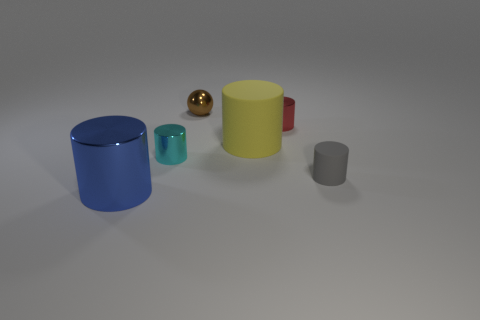There is a big yellow thing that is the same shape as the gray thing; what is it made of? The big yellow object, which has the same cylindrical shape as the smaller gray one, appears to be made of a matte plastic material, commonly used for various containers or decorative elements. 